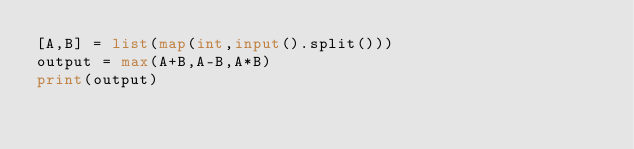<code> <loc_0><loc_0><loc_500><loc_500><_Python_>[A,B] = list(map(int,input().split()))
output = max(A+B,A-B,A*B)
print(output)</code> 